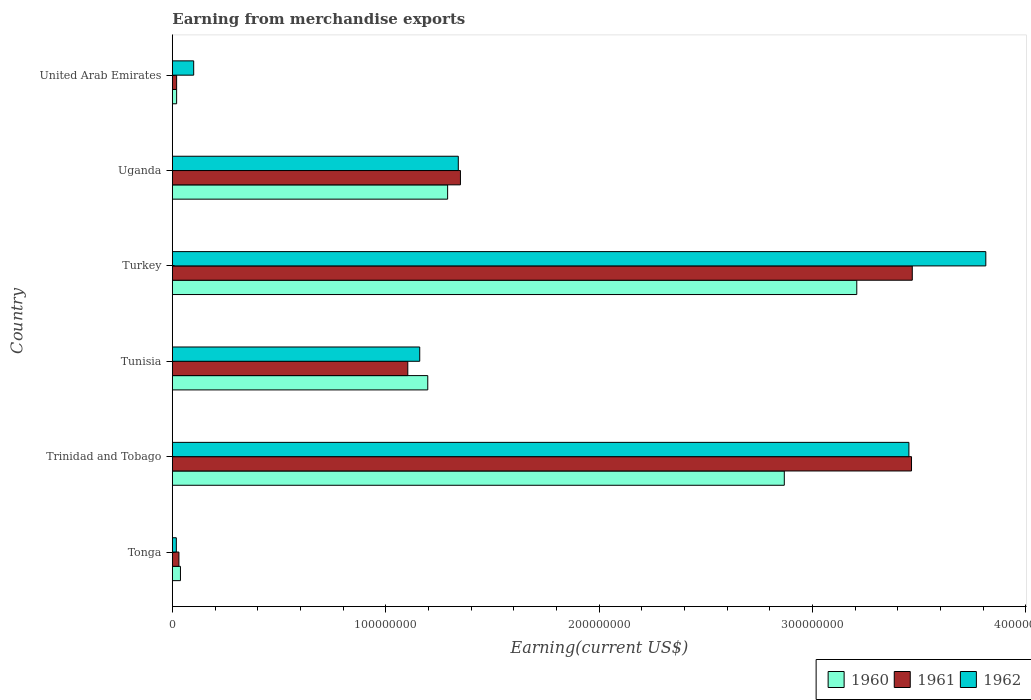Are the number of bars per tick equal to the number of legend labels?
Provide a short and direct response. Yes. Are the number of bars on each tick of the Y-axis equal?
Offer a terse response. Yes. What is the label of the 2nd group of bars from the top?
Your answer should be compact. Uganda. What is the amount earned from merchandise exports in 1962 in Turkey?
Provide a succinct answer. 3.81e+08. Across all countries, what is the maximum amount earned from merchandise exports in 1960?
Provide a succinct answer. 3.21e+08. Across all countries, what is the minimum amount earned from merchandise exports in 1962?
Provide a short and direct response. 1.87e+06. In which country was the amount earned from merchandise exports in 1960 maximum?
Your answer should be compact. Turkey. In which country was the amount earned from merchandise exports in 1962 minimum?
Ensure brevity in your answer.  Tonga. What is the total amount earned from merchandise exports in 1960 in the graph?
Offer a very short reply. 8.62e+08. What is the difference between the amount earned from merchandise exports in 1962 in Turkey and that in United Arab Emirates?
Give a very brief answer. 3.71e+08. What is the difference between the amount earned from merchandise exports in 1962 in Uganda and the amount earned from merchandise exports in 1960 in Tunisia?
Your response must be concise. 1.43e+07. What is the average amount earned from merchandise exports in 1960 per country?
Your answer should be very brief. 1.44e+08. What is the ratio of the amount earned from merchandise exports in 1961 in Tonga to that in United Arab Emirates?
Your answer should be compact. 1.54. Is the difference between the amount earned from merchandise exports in 1962 in Tonga and Turkey greater than the difference between the amount earned from merchandise exports in 1961 in Tonga and Turkey?
Keep it short and to the point. No. What is the difference between the highest and the second highest amount earned from merchandise exports in 1961?
Your answer should be very brief. 3.58e+05. What is the difference between the highest and the lowest amount earned from merchandise exports in 1960?
Give a very brief answer. 3.19e+08. Is the sum of the amount earned from merchandise exports in 1960 in Turkey and Uganda greater than the maximum amount earned from merchandise exports in 1962 across all countries?
Your answer should be compact. Yes. How many countries are there in the graph?
Your answer should be very brief. 6. Are the values on the major ticks of X-axis written in scientific E-notation?
Make the answer very short. No. Does the graph contain any zero values?
Offer a very short reply. No. Does the graph contain grids?
Give a very brief answer. No. What is the title of the graph?
Offer a terse response. Earning from merchandise exports. What is the label or title of the X-axis?
Keep it short and to the point. Earning(current US$). What is the Earning(current US$) of 1960 in Tonga?
Provide a succinct answer. 3.80e+06. What is the Earning(current US$) in 1961 in Tonga?
Offer a terse response. 3.08e+06. What is the Earning(current US$) in 1962 in Tonga?
Keep it short and to the point. 1.87e+06. What is the Earning(current US$) of 1960 in Trinidad and Tobago?
Ensure brevity in your answer.  2.87e+08. What is the Earning(current US$) of 1961 in Trinidad and Tobago?
Your response must be concise. 3.46e+08. What is the Earning(current US$) of 1962 in Trinidad and Tobago?
Offer a very short reply. 3.45e+08. What is the Earning(current US$) in 1960 in Tunisia?
Your answer should be very brief. 1.20e+08. What is the Earning(current US$) of 1961 in Tunisia?
Offer a very short reply. 1.10e+08. What is the Earning(current US$) of 1962 in Tunisia?
Offer a terse response. 1.16e+08. What is the Earning(current US$) in 1960 in Turkey?
Keep it short and to the point. 3.21e+08. What is the Earning(current US$) of 1961 in Turkey?
Provide a short and direct response. 3.47e+08. What is the Earning(current US$) of 1962 in Turkey?
Keep it short and to the point. 3.81e+08. What is the Earning(current US$) of 1960 in Uganda?
Ensure brevity in your answer.  1.29e+08. What is the Earning(current US$) in 1961 in Uganda?
Keep it short and to the point. 1.35e+08. What is the Earning(current US$) in 1962 in Uganda?
Offer a very short reply. 1.34e+08. What is the Earning(current US$) in 1962 in United Arab Emirates?
Give a very brief answer. 1.00e+07. Across all countries, what is the maximum Earning(current US$) in 1960?
Give a very brief answer. 3.21e+08. Across all countries, what is the maximum Earning(current US$) in 1961?
Make the answer very short. 3.47e+08. Across all countries, what is the maximum Earning(current US$) of 1962?
Make the answer very short. 3.81e+08. Across all countries, what is the minimum Earning(current US$) in 1961?
Make the answer very short. 2.00e+06. Across all countries, what is the minimum Earning(current US$) of 1962?
Give a very brief answer. 1.87e+06. What is the total Earning(current US$) in 1960 in the graph?
Make the answer very short. 8.62e+08. What is the total Earning(current US$) in 1961 in the graph?
Provide a succinct answer. 9.44e+08. What is the total Earning(current US$) of 1962 in the graph?
Provide a succinct answer. 9.88e+08. What is the difference between the Earning(current US$) in 1960 in Tonga and that in Trinidad and Tobago?
Your answer should be compact. -2.83e+08. What is the difference between the Earning(current US$) in 1961 in Tonga and that in Trinidad and Tobago?
Give a very brief answer. -3.43e+08. What is the difference between the Earning(current US$) in 1962 in Tonga and that in Trinidad and Tobago?
Make the answer very short. -3.43e+08. What is the difference between the Earning(current US$) in 1960 in Tonga and that in Tunisia?
Offer a very short reply. -1.16e+08. What is the difference between the Earning(current US$) of 1961 in Tonga and that in Tunisia?
Make the answer very short. -1.07e+08. What is the difference between the Earning(current US$) in 1962 in Tonga and that in Tunisia?
Your response must be concise. -1.14e+08. What is the difference between the Earning(current US$) of 1960 in Tonga and that in Turkey?
Your answer should be compact. -3.17e+08. What is the difference between the Earning(current US$) in 1961 in Tonga and that in Turkey?
Give a very brief answer. -3.44e+08. What is the difference between the Earning(current US$) in 1962 in Tonga and that in Turkey?
Your answer should be very brief. -3.79e+08. What is the difference between the Earning(current US$) of 1960 in Tonga and that in Uganda?
Keep it short and to the point. -1.25e+08. What is the difference between the Earning(current US$) in 1961 in Tonga and that in Uganda?
Give a very brief answer. -1.32e+08. What is the difference between the Earning(current US$) in 1962 in Tonga and that in Uganda?
Provide a short and direct response. -1.32e+08. What is the difference between the Earning(current US$) in 1960 in Tonga and that in United Arab Emirates?
Keep it short and to the point. 1.80e+06. What is the difference between the Earning(current US$) in 1961 in Tonga and that in United Arab Emirates?
Ensure brevity in your answer.  1.08e+06. What is the difference between the Earning(current US$) of 1962 in Tonga and that in United Arab Emirates?
Ensure brevity in your answer.  -8.13e+06. What is the difference between the Earning(current US$) of 1960 in Trinidad and Tobago and that in Tunisia?
Make the answer very short. 1.67e+08. What is the difference between the Earning(current US$) in 1961 in Trinidad and Tobago and that in Tunisia?
Provide a succinct answer. 2.36e+08. What is the difference between the Earning(current US$) of 1962 in Trinidad and Tobago and that in Tunisia?
Make the answer very short. 2.29e+08. What is the difference between the Earning(current US$) in 1960 in Trinidad and Tobago and that in Turkey?
Make the answer very short. -3.40e+07. What is the difference between the Earning(current US$) in 1961 in Trinidad and Tobago and that in Turkey?
Make the answer very short. -3.58e+05. What is the difference between the Earning(current US$) of 1962 in Trinidad and Tobago and that in Turkey?
Your answer should be compact. -3.60e+07. What is the difference between the Earning(current US$) in 1960 in Trinidad and Tobago and that in Uganda?
Your answer should be compact. 1.58e+08. What is the difference between the Earning(current US$) in 1961 in Trinidad and Tobago and that in Uganda?
Your answer should be compact. 2.11e+08. What is the difference between the Earning(current US$) of 1962 in Trinidad and Tobago and that in Uganda?
Your answer should be very brief. 2.11e+08. What is the difference between the Earning(current US$) in 1960 in Trinidad and Tobago and that in United Arab Emirates?
Your answer should be very brief. 2.85e+08. What is the difference between the Earning(current US$) in 1961 in Trinidad and Tobago and that in United Arab Emirates?
Keep it short and to the point. 3.44e+08. What is the difference between the Earning(current US$) in 1962 in Trinidad and Tobago and that in United Arab Emirates?
Offer a very short reply. 3.35e+08. What is the difference between the Earning(current US$) of 1960 in Tunisia and that in Turkey?
Your response must be concise. -2.01e+08. What is the difference between the Earning(current US$) of 1961 in Tunisia and that in Turkey?
Your response must be concise. -2.36e+08. What is the difference between the Earning(current US$) of 1962 in Tunisia and that in Turkey?
Give a very brief answer. -2.65e+08. What is the difference between the Earning(current US$) of 1960 in Tunisia and that in Uganda?
Give a very brief answer. -9.31e+06. What is the difference between the Earning(current US$) of 1961 in Tunisia and that in Uganda?
Offer a very short reply. -2.47e+07. What is the difference between the Earning(current US$) of 1962 in Tunisia and that in Uganda?
Ensure brevity in your answer.  -1.81e+07. What is the difference between the Earning(current US$) of 1960 in Tunisia and that in United Arab Emirates?
Provide a short and direct response. 1.18e+08. What is the difference between the Earning(current US$) in 1961 in Tunisia and that in United Arab Emirates?
Offer a terse response. 1.08e+08. What is the difference between the Earning(current US$) in 1962 in Tunisia and that in United Arab Emirates?
Give a very brief answer. 1.06e+08. What is the difference between the Earning(current US$) of 1960 in Turkey and that in Uganda?
Provide a short and direct response. 1.92e+08. What is the difference between the Earning(current US$) of 1961 in Turkey and that in Uganda?
Your response must be concise. 2.12e+08. What is the difference between the Earning(current US$) of 1962 in Turkey and that in Uganda?
Your answer should be compact. 2.47e+08. What is the difference between the Earning(current US$) in 1960 in Turkey and that in United Arab Emirates?
Your answer should be very brief. 3.19e+08. What is the difference between the Earning(current US$) in 1961 in Turkey and that in United Arab Emirates?
Keep it short and to the point. 3.45e+08. What is the difference between the Earning(current US$) of 1962 in Turkey and that in United Arab Emirates?
Keep it short and to the point. 3.71e+08. What is the difference between the Earning(current US$) in 1960 in Uganda and that in United Arab Emirates?
Provide a succinct answer. 1.27e+08. What is the difference between the Earning(current US$) in 1961 in Uganda and that in United Arab Emirates?
Offer a terse response. 1.33e+08. What is the difference between the Earning(current US$) of 1962 in Uganda and that in United Arab Emirates?
Provide a succinct answer. 1.24e+08. What is the difference between the Earning(current US$) of 1960 in Tonga and the Earning(current US$) of 1961 in Trinidad and Tobago?
Your answer should be very brief. -3.43e+08. What is the difference between the Earning(current US$) of 1960 in Tonga and the Earning(current US$) of 1962 in Trinidad and Tobago?
Provide a short and direct response. -3.41e+08. What is the difference between the Earning(current US$) of 1961 in Tonga and the Earning(current US$) of 1962 in Trinidad and Tobago?
Your response must be concise. -3.42e+08. What is the difference between the Earning(current US$) of 1960 in Tonga and the Earning(current US$) of 1961 in Tunisia?
Offer a terse response. -1.07e+08. What is the difference between the Earning(current US$) of 1960 in Tonga and the Earning(current US$) of 1962 in Tunisia?
Offer a terse response. -1.12e+08. What is the difference between the Earning(current US$) in 1961 in Tonga and the Earning(current US$) in 1962 in Tunisia?
Make the answer very short. -1.13e+08. What is the difference between the Earning(current US$) in 1960 in Tonga and the Earning(current US$) in 1961 in Turkey?
Make the answer very short. -3.43e+08. What is the difference between the Earning(current US$) in 1960 in Tonga and the Earning(current US$) in 1962 in Turkey?
Your answer should be very brief. -3.77e+08. What is the difference between the Earning(current US$) in 1961 in Tonga and the Earning(current US$) in 1962 in Turkey?
Ensure brevity in your answer.  -3.78e+08. What is the difference between the Earning(current US$) of 1960 in Tonga and the Earning(current US$) of 1961 in Uganda?
Give a very brief answer. -1.31e+08. What is the difference between the Earning(current US$) of 1960 in Tonga and the Earning(current US$) of 1962 in Uganda?
Keep it short and to the point. -1.30e+08. What is the difference between the Earning(current US$) of 1961 in Tonga and the Earning(current US$) of 1962 in Uganda?
Provide a short and direct response. -1.31e+08. What is the difference between the Earning(current US$) of 1960 in Tonga and the Earning(current US$) of 1961 in United Arab Emirates?
Provide a succinct answer. 1.80e+06. What is the difference between the Earning(current US$) of 1960 in Tonga and the Earning(current US$) of 1962 in United Arab Emirates?
Your response must be concise. -6.20e+06. What is the difference between the Earning(current US$) in 1961 in Tonga and the Earning(current US$) in 1962 in United Arab Emirates?
Offer a very short reply. -6.92e+06. What is the difference between the Earning(current US$) in 1960 in Trinidad and Tobago and the Earning(current US$) in 1961 in Tunisia?
Your answer should be compact. 1.76e+08. What is the difference between the Earning(current US$) of 1960 in Trinidad and Tobago and the Earning(current US$) of 1962 in Tunisia?
Your response must be concise. 1.71e+08. What is the difference between the Earning(current US$) of 1961 in Trinidad and Tobago and the Earning(current US$) of 1962 in Tunisia?
Offer a very short reply. 2.30e+08. What is the difference between the Earning(current US$) in 1960 in Trinidad and Tobago and the Earning(current US$) in 1961 in Turkey?
Your answer should be very brief. -6.00e+07. What is the difference between the Earning(current US$) of 1960 in Trinidad and Tobago and the Earning(current US$) of 1962 in Turkey?
Provide a short and direct response. -9.44e+07. What is the difference between the Earning(current US$) of 1961 in Trinidad and Tobago and the Earning(current US$) of 1962 in Turkey?
Ensure brevity in your answer.  -3.48e+07. What is the difference between the Earning(current US$) of 1960 in Trinidad and Tobago and the Earning(current US$) of 1961 in Uganda?
Ensure brevity in your answer.  1.52e+08. What is the difference between the Earning(current US$) of 1960 in Trinidad and Tobago and the Earning(current US$) of 1962 in Uganda?
Give a very brief answer. 1.53e+08. What is the difference between the Earning(current US$) in 1961 in Trinidad and Tobago and the Earning(current US$) in 1962 in Uganda?
Offer a terse response. 2.12e+08. What is the difference between the Earning(current US$) in 1960 in Trinidad and Tobago and the Earning(current US$) in 1961 in United Arab Emirates?
Offer a very short reply. 2.85e+08. What is the difference between the Earning(current US$) in 1960 in Trinidad and Tobago and the Earning(current US$) in 1962 in United Arab Emirates?
Your answer should be very brief. 2.77e+08. What is the difference between the Earning(current US$) in 1961 in Trinidad and Tobago and the Earning(current US$) in 1962 in United Arab Emirates?
Provide a succinct answer. 3.36e+08. What is the difference between the Earning(current US$) in 1960 in Tunisia and the Earning(current US$) in 1961 in Turkey?
Your answer should be compact. -2.27e+08. What is the difference between the Earning(current US$) in 1960 in Tunisia and the Earning(current US$) in 1962 in Turkey?
Provide a succinct answer. -2.62e+08. What is the difference between the Earning(current US$) in 1961 in Tunisia and the Earning(current US$) in 1962 in Turkey?
Provide a short and direct response. -2.71e+08. What is the difference between the Earning(current US$) of 1960 in Tunisia and the Earning(current US$) of 1961 in Uganda?
Offer a terse response. -1.53e+07. What is the difference between the Earning(current US$) in 1960 in Tunisia and the Earning(current US$) in 1962 in Uganda?
Offer a terse response. -1.43e+07. What is the difference between the Earning(current US$) in 1961 in Tunisia and the Earning(current US$) in 1962 in Uganda?
Keep it short and to the point. -2.37e+07. What is the difference between the Earning(current US$) in 1960 in Tunisia and the Earning(current US$) in 1961 in United Arab Emirates?
Provide a short and direct response. 1.18e+08. What is the difference between the Earning(current US$) in 1960 in Tunisia and the Earning(current US$) in 1962 in United Arab Emirates?
Keep it short and to the point. 1.10e+08. What is the difference between the Earning(current US$) in 1961 in Tunisia and the Earning(current US$) in 1962 in United Arab Emirates?
Your answer should be compact. 1.00e+08. What is the difference between the Earning(current US$) in 1960 in Turkey and the Earning(current US$) in 1961 in Uganda?
Provide a succinct answer. 1.86e+08. What is the difference between the Earning(current US$) in 1960 in Turkey and the Earning(current US$) in 1962 in Uganda?
Make the answer very short. 1.87e+08. What is the difference between the Earning(current US$) of 1961 in Turkey and the Earning(current US$) of 1962 in Uganda?
Offer a terse response. 2.13e+08. What is the difference between the Earning(current US$) in 1960 in Turkey and the Earning(current US$) in 1961 in United Arab Emirates?
Provide a short and direct response. 3.19e+08. What is the difference between the Earning(current US$) in 1960 in Turkey and the Earning(current US$) in 1962 in United Arab Emirates?
Your answer should be compact. 3.11e+08. What is the difference between the Earning(current US$) in 1961 in Turkey and the Earning(current US$) in 1962 in United Arab Emirates?
Keep it short and to the point. 3.37e+08. What is the difference between the Earning(current US$) of 1960 in Uganda and the Earning(current US$) of 1961 in United Arab Emirates?
Keep it short and to the point. 1.27e+08. What is the difference between the Earning(current US$) of 1960 in Uganda and the Earning(current US$) of 1962 in United Arab Emirates?
Give a very brief answer. 1.19e+08. What is the difference between the Earning(current US$) in 1961 in Uganda and the Earning(current US$) in 1962 in United Arab Emirates?
Your answer should be compact. 1.25e+08. What is the average Earning(current US$) of 1960 per country?
Offer a very short reply. 1.44e+08. What is the average Earning(current US$) of 1961 per country?
Offer a very short reply. 1.57e+08. What is the average Earning(current US$) in 1962 per country?
Ensure brevity in your answer.  1.65e+08. What is the difference between the Earning(current US$) in 1960 and Earning(current US$) in 1961 in Tonga?
Give a very brief answer. 7.21e+05. What is the difference between the Earning(current US$) of 1960 and Earning(current US$) of 1962 in Tonga?
Provide a succinct answer. 1.93e+06. What is the difference between the Earning(current US$) of 1961 and Earning(current US$) of 1962 in Tonga?
Ensure brevity in your answer.  1.21e+06. What is the difference between the Earning(current US$) in 1960 and Earning(current US$) in 1961 in Trinidad and Tobago?
Make the answer very short. -5.96e+07. What is the difference between the Earning(current US$) of 1960 and Earning(current US$) of 1962 in Trinidad and Tobago?
Make the answer very short. -5.84e+07. What is the difference between the Earning(current US$) of 1961 and Earning(current US$) of 1962 in Trinidad and Tobago?
Keep it short and to the point. 1.22e+06. What is the difference between the Earning(current US$) in 1960 and Earning(current US$) in 1961 in Tunisia?
Offer a terse response. 9.36e+06. What is the difference between the Earning(current US$) of 1960 and Earning(current US$) of 1962 in Tunisia?
Your answer should be very brief. 3.76e+06. What is the difference between the Earning(current US$) of 1961 and Earning(current US$) of 1962 in Tunisia?
Provide a succinct answer. -5.60e+06. What is the difference between the Earning(current US$) of 1960 and Earning(current US$) of 1961 in Turkey?
Your answer should be compact. -2.60e+07. What is the difference between the Earning(current US$) in 1960 and Earning(current US$) in 1962 in Turkey?
Your answer should be compact. -6.05e+07. What is the difference between the Earning(current US$) in 1961 and Earning(current US$) in 1962 in Turkey?
Your answer should be very brief. -3.45e+07. What is the difference between the Earning(current US$) in 1960 and Earning(current US$) in 1961 in Uganda?
Make the answer very short. -6.00e+06. What is the difference between the Earning(current US$) in 1960 and Earning(current US$) in 1962 in Uganda?
Your answer should be compact. -5.00e+06. What is the difference between the Earning(current US$) in 1960 and Earning(current US$) in 1962 in United Arab Emirates?
Your answer should be compact. -8.00e+06. What is the difference between the Earning(current US$) in 1961 and Earning(current US$) in 1962 in United Arab Emirates?
Provide a succinct answer. -8.00e+06. What is the ratio of the Earning(current US$) in 1960 in Tonga to that in Trinidad and Tobago?
Give a very brief answer. 0.01. What is the ratio of the Earning(current US$) of 1961 in Tonga to that in Trinidad and Tobago?
Your answer should be very brief. 0.01. What is the ratio of the Earning(current US$) of 1962 in Tonga to that in Trinidad and Tobago?
Ensure brevity in your answer.  0.01. What is the ratio of the Earning(current US$) of 1960 in Tonga to that in Tunisia?
Ensure brevity in your answer.  0.03. What is the ratio of the Earning(current US$) of 1961 in Tonga to that in Tunisia?
Your answer should be very brief. 0.03. What is the ratio of the Earning(current US$) in 1962 in Tonga to that in Tunisia?
Ensure brevity in your answer.  0.02. What is the ratio of the Earning(current US$) in 1960 in Tonga to that in Turkey?
Provide a succinct answer. 0.01. What is the ratio of the Earning(current US$) of 1961 in Tonga to that in Turkey?
Your response must be concise. 0.01. What is the ratio of the Earning(current US$) of 1962 in Tonga to that in Turkey?
Your answer should be compact. 0. What is the ratio of the Earning(current US$) of 1960 in Tonga to that in Uganda?
Offer a terse response. 0.03. What is the ratio of the Earning(current US$) in 1961 in Tonga to that in Uganda?
Offer a terse response. 0.02. What is the ratio of the Earning(current US$) of 1962 in Tonga to that in Uganda?
Provide a short and direct response. 0.01. What is the ratio of the Earning(current US$) of 1960 in Tonga to that in United Arab Emirates?
Your answer should be compact. 1.9. What is the ratio of the Earning(current US$) in 1961 in Tonga to that in United Arab Emirates?
Offer a terse response. 1.54. What is the ratio of the Earning(current US$) in 1962 in Tonga to that in United Arab Emirates?
Your answer should be very brief. 0.19. What is the ratio of the Earning(current US$) of 1960 in Trinidad and Tobago to that in Tunisia?
Make the answer very short. 2.4. What is the ratio of the Earning(current US$) of 1961 in Trinidad and Tobago to that in Tunisia?
Make the answer very short. 3.14. What is the ratio of the Earning(current US$) in 1962 in Trinidad and Tobago to that in Tunisia?
Your answer should be compact. 2.98. What is the ratio of the Earning(current US$) of 1960 in Trinidad and Tobago to that in Turkey?
Ensure brevity in your answer.  0.89. What is the ratio of the Earning(current US$) of 1961 in Trinidad and Tobago to that in Turkey?
Your response must be concise. 1. What is the ratio of the Earning(current US$) in 1962 in Trinidad and Tobago to that in Turkey?
Provide a succinct answer. 0.91. What is the ratio of the Earning(current US$) in 1960 in Trinidad and Tobago to that in Uganda?
Offer a terse response. 2.22. What is the ratio of the Earning(current US$) in 1961 in Trinidad and Tobago to that in Uganda?
Give a very brief answer. 2.57. What is the ratio of the Earning(current US$) of 1962 in Trinidad and Tobago to that in Uganda?
Your response must be concise. 2.58. What is the ratio of the Earning(current US$) of 1960 in Trinidad and Tobago to that in United Arab Emirates?
Your answer should be compact. 143.38. What is the ratio of the Earning(current US$) of 1961 in Trinidad and Tobago to that in United Arab Emirates?
Provide a short and direct response. 173.19. What is the ratio of the Earning(current US$) of 1962 in Trinidad and Tobago to that in United Arab Emirates?
Provide a succinct answer. 34.52. What is the ratio of the Earning(current US$) in 1960 in Tunisia to that in Turkey?
Offer a very short reply. 0.37. What is the ratio of the Earning(current US$) of 1961 in Tunisia to that in Turkey?
Your answer should be very brief. 0.32. What is the ratio of the Earning(current US$) in 1962 in Tunisia to that in Turkey?
Offer a terse response. 0.3. What is the ratio of the Earning(current US$) of 1960 in Tunisia to that in Uganda?
Provide a short and direct response. 0.93. What is the ratio of the Earning(current US$) of 1961 in Tunisia to that in Uganda?
Provide a succinct answer. 0.82. What is the ratio of the Earning(current US$) in 1962 in Tunisia to that in Uganda?
Provide a succinct answer. 0.87. What is the ratio of the Earning(current US$) of 1960 in Tunisia to that in United Arab Emirates?
Your response must be concise. 59.84. What is the ratio of the Earning(current US$) of 1961 in Tunisia to that in United Arab Emirates?
Provide a short and direct response. 55.17. What is the ratio of the Earning(current US$) of 1962 in Tunisia to that in United Arab Emirates?
Give a very brief answer. 11.59. What is the ratio of the Earning(current US$) in 1960 in Turkey to that in Uganda?
Offer a very short reply. 2.49. What is the ratio of the Earning(current US$) in 1961 in Turkey to that in Uganda?
Give a very brief answer. 2.57. What is the ratio of the Earning(current US$) in 1962 in Turkey to that in Uganda?
Provide a succinct answer. 2.84. What is the ratio of the Earning(current US$) in 1960 in Turkey to that in United Arab Emirates?
Provide a succinct answer. 160.37. What is the ratio of the Earning(current US$) in 1961 in Turkey to that in United Arab Emirates?
Make the answer very short. 173.37. What is the ratio of the Earning(current US$) of 1962 in Turkey to that in United Arab Emirates?
Your answer should be compact. 38.12. What is the ratio of the Earning(current US$) of 1960 in Uganda to that in United Arab Emirates?
Ensure brevity in your answer.  64.5. What is the ratio of the Earning(current US$) of 1961 in Uganda to that in United Arab Emirates?
Your answer should be compact. 67.5. What is the difference between the highest and the second highest Earning(current US$) in 1960?
Your response must be concise. 3.40e+07. What is the difference between the highest and the second highest Earning(current US$) in 1961?
Ensure brevity in your answer.  3.58e+05. What is the difference between the highest and the second highest Earning(current US$) of 1962?
Your answer should be compact. 3.60e+07. What is the difference between the highest and the lowest Earning(current US$) of 1960?
Offer a very short reply. 3.19e+08. What is the difference between the highest and the lowest Earning(current US$) of 1961?
Offer a very short reply. 3.45e+08. What is the difference between the highest and the lowest Earning(current US$) in 1962?
Offer a very short reply. 3.79e+08. 